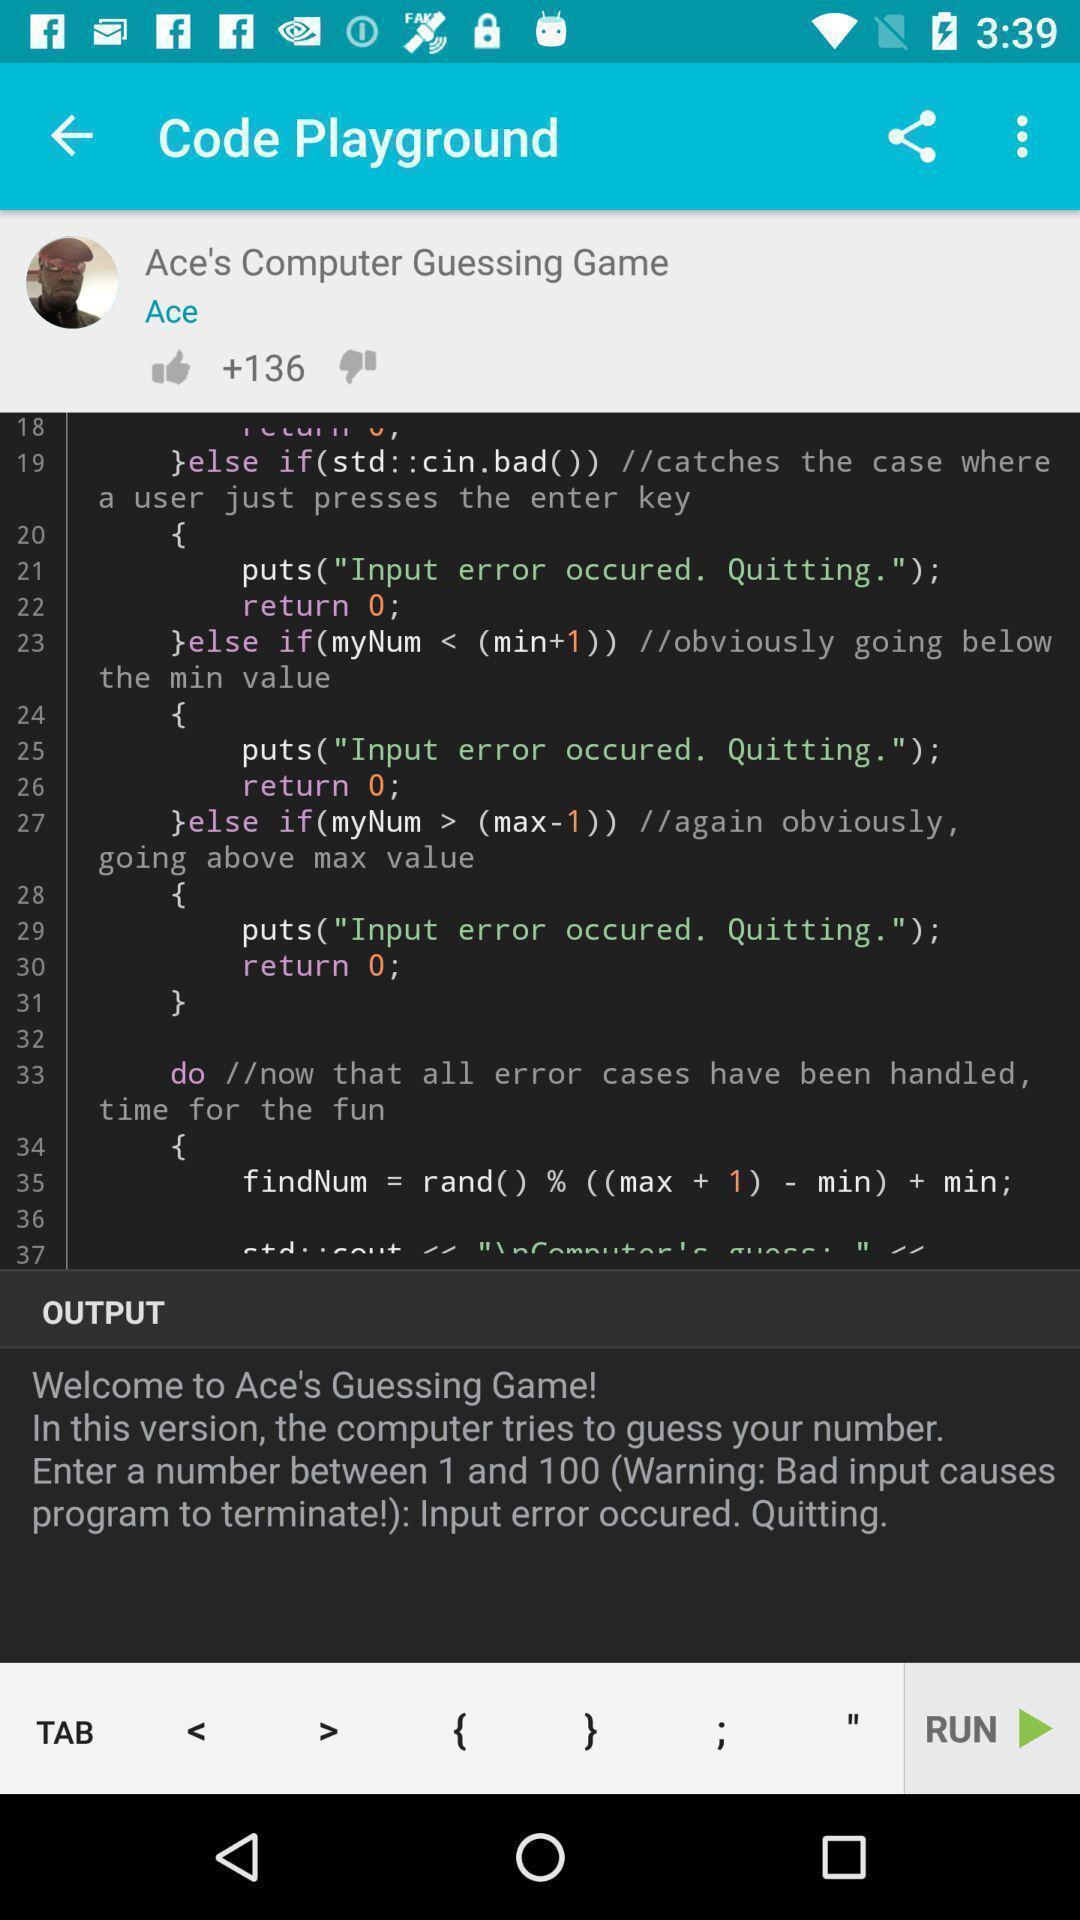Summarize the information in this screenshot. Page displaying software code in a coding app. 